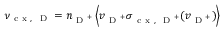<formula> <loc_0><loc_0><loc_500><loc_500>\nu _ { c x , D } = n _ { D ^ { + } } \left \langle v _ { D ^ { + } } \sigma _ { c x , D ^ { + } } ( v _ { D ^ { + } } ) \right \rangle</formula> 